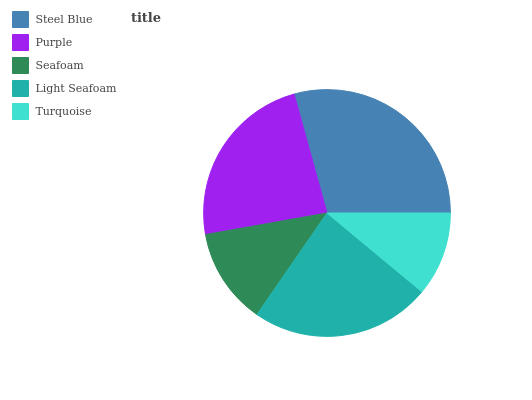Is Turquoise the minimum?
Answer yes or no. Yes. Is Steel Blue the maximum?
Answer yes or no. Yes. Is Purple the minimum?
Answer yes or no. No. Is Purple the maximum?
Answer yes or no. No. Is Steel Blue greater than Purple?
Answer yes or no. Yes. Is Purple less than Steel Blue?
Answer yes or no. Yes. Is Purple greater than Steel Blue?
Answer yes or no. No. Is Steel Blue less than Purple?
Answer yes or no. No. Is Purple the high median?
Answer yes or no. Yes. Is Purple the low median?
Answer yes or no. Yes. Is Steel Blue the high median?
Answer yes or no. No. Is Seafoam the low median?
Answer yes or no. No. 